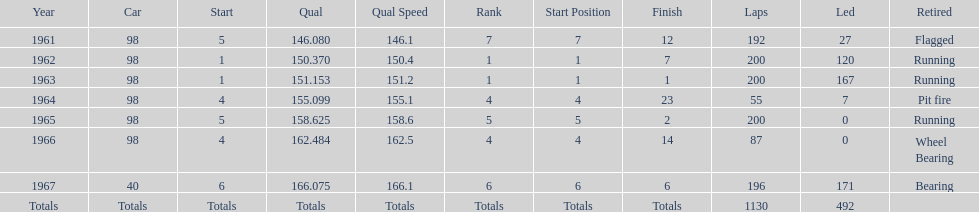How many times did he finish in the top three? 2. 